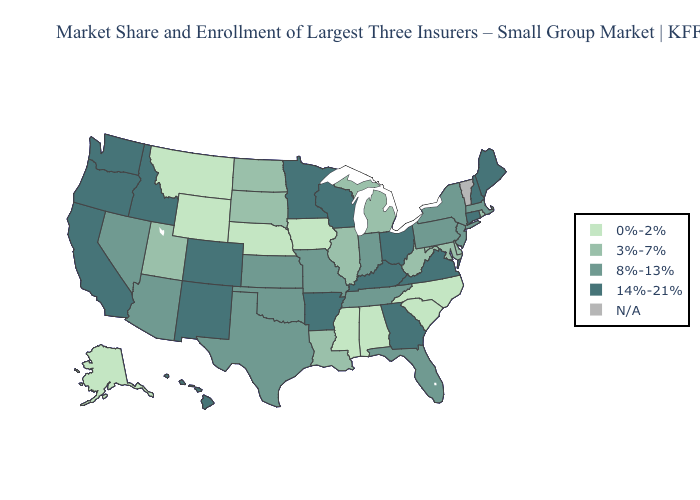Name the states that have a value in the range 14%-21%?
Answer briefly. Arkansas, California, Colorado, Connecticut, Georgia, Hawaii, Idaho, Kentucky, Maine, Minnesota, New Hampshire, New Mexico, Ohio, Oregon, Virginia, Washington, Wisconsin. Does the first symbol in the legend represent the smallest category?
Concise answer only. Yes. Does Mississippi have the highest value in the South?
Keep it brief. No. Does Colorado have the highest value in the West?
Keep it brief. Yes. What is the value of Kentucky?
Give a very brief answer. 14%-21%. What is the value of South Dakota?
Keep it brief. 3%-7%. What is the value of Montana?
Concise answer only. 0%-2%. Which states have the lowest value in the USA?
Be succinct. Alabama, Alaska, Iowa, Mississippi, Montana, Nebraska, North Carolina, South Carolina, Wyoming. Which states have the lowest value in the Northeast?
Keep it brief. Rhode Island. Which states hav the highest value in the South?
Be succinct. Arkansas, Georgia, Kentucky, Virginia. What is the highest value in states that border South Dakota?
Short answer required. 14%-21%. What is the lowest value in the USA?
Short answer required. 0%-2%. Does the map have missing data?
Give a very brief answer. Yes. 